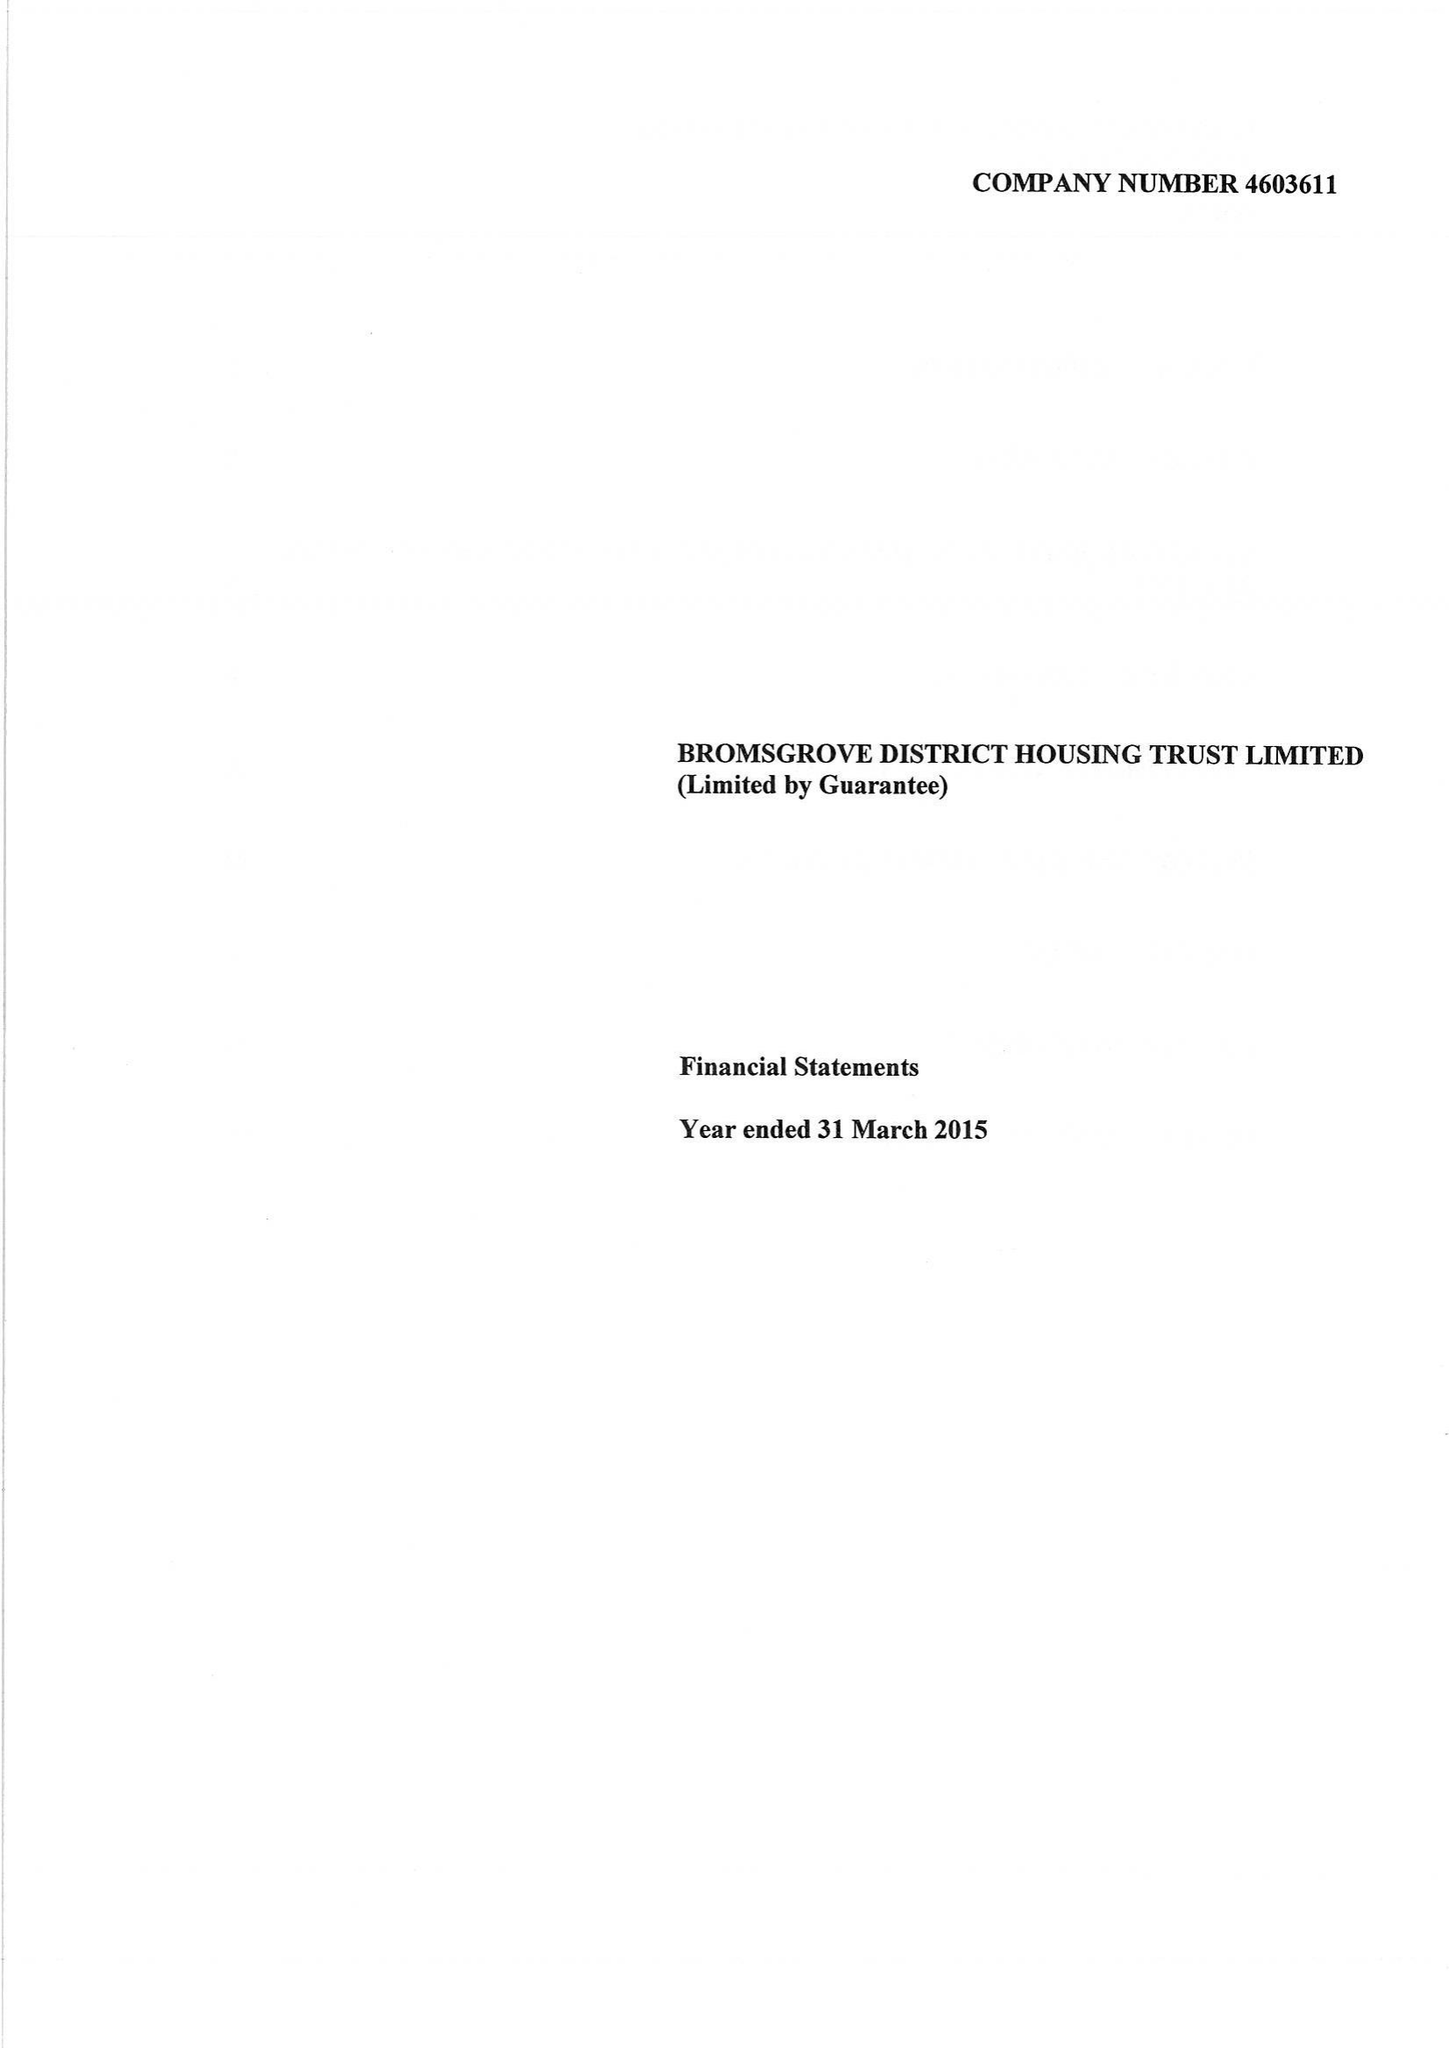What is the value for the report_date?
Answer the question using a single word or phrase. 2015-03-31 